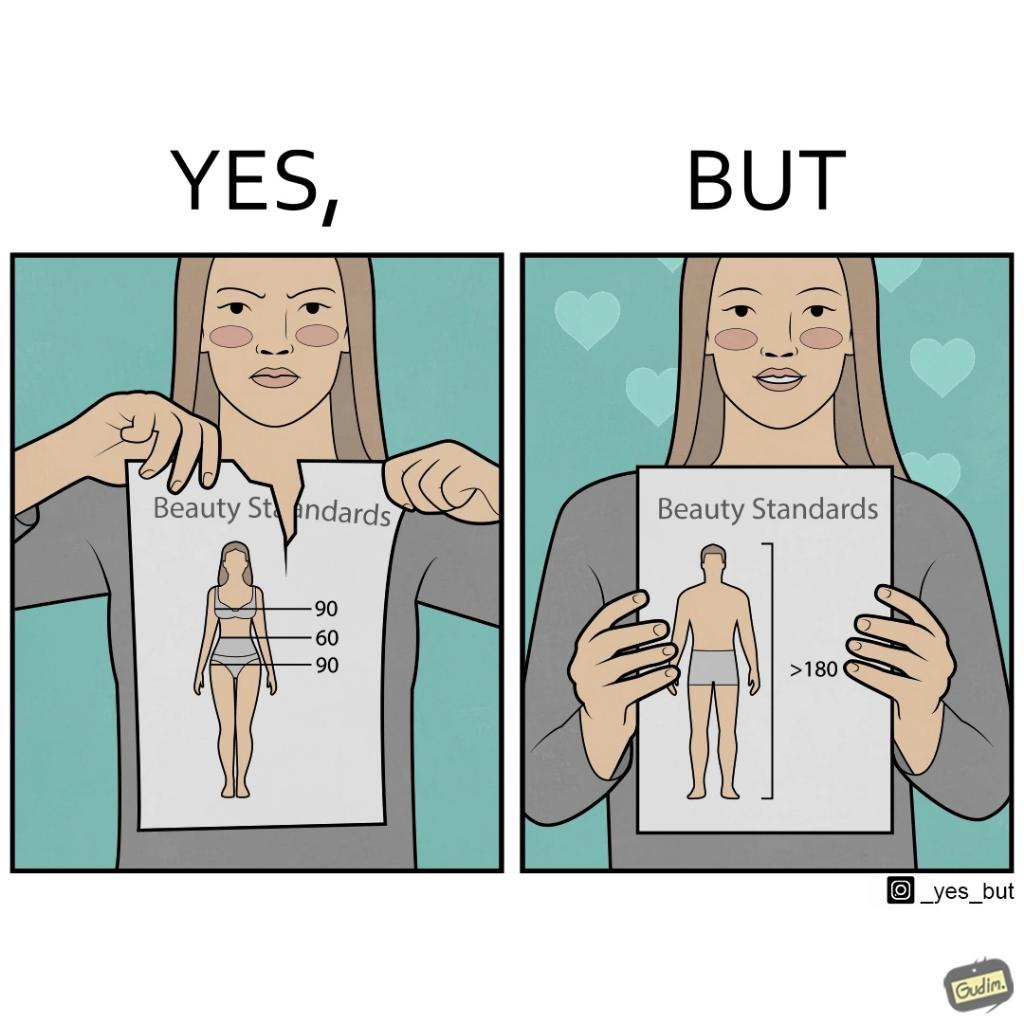Why is this image considered satirical? The image is ironic because the woman that is angry about having constraints set on the body parts of a woman to be considered beautiful is the same person who is happily presenting contraints on the height of a man to be considered beautiful. 